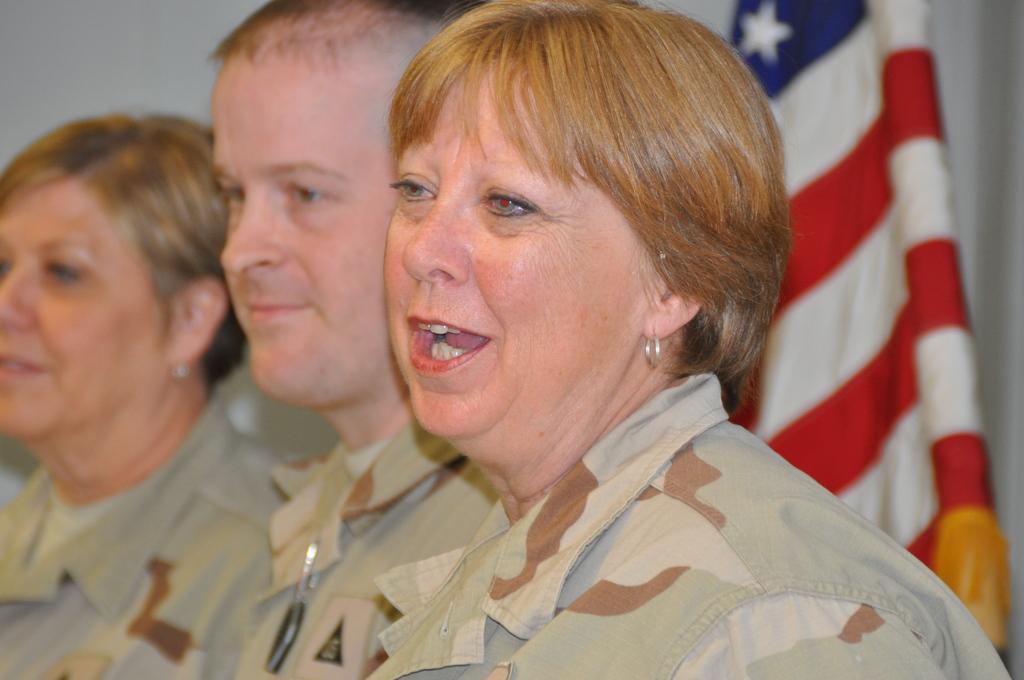How would you summarize this image in a sentence or two? In the image three persons are standing and smiling. Behind them there is flag. 